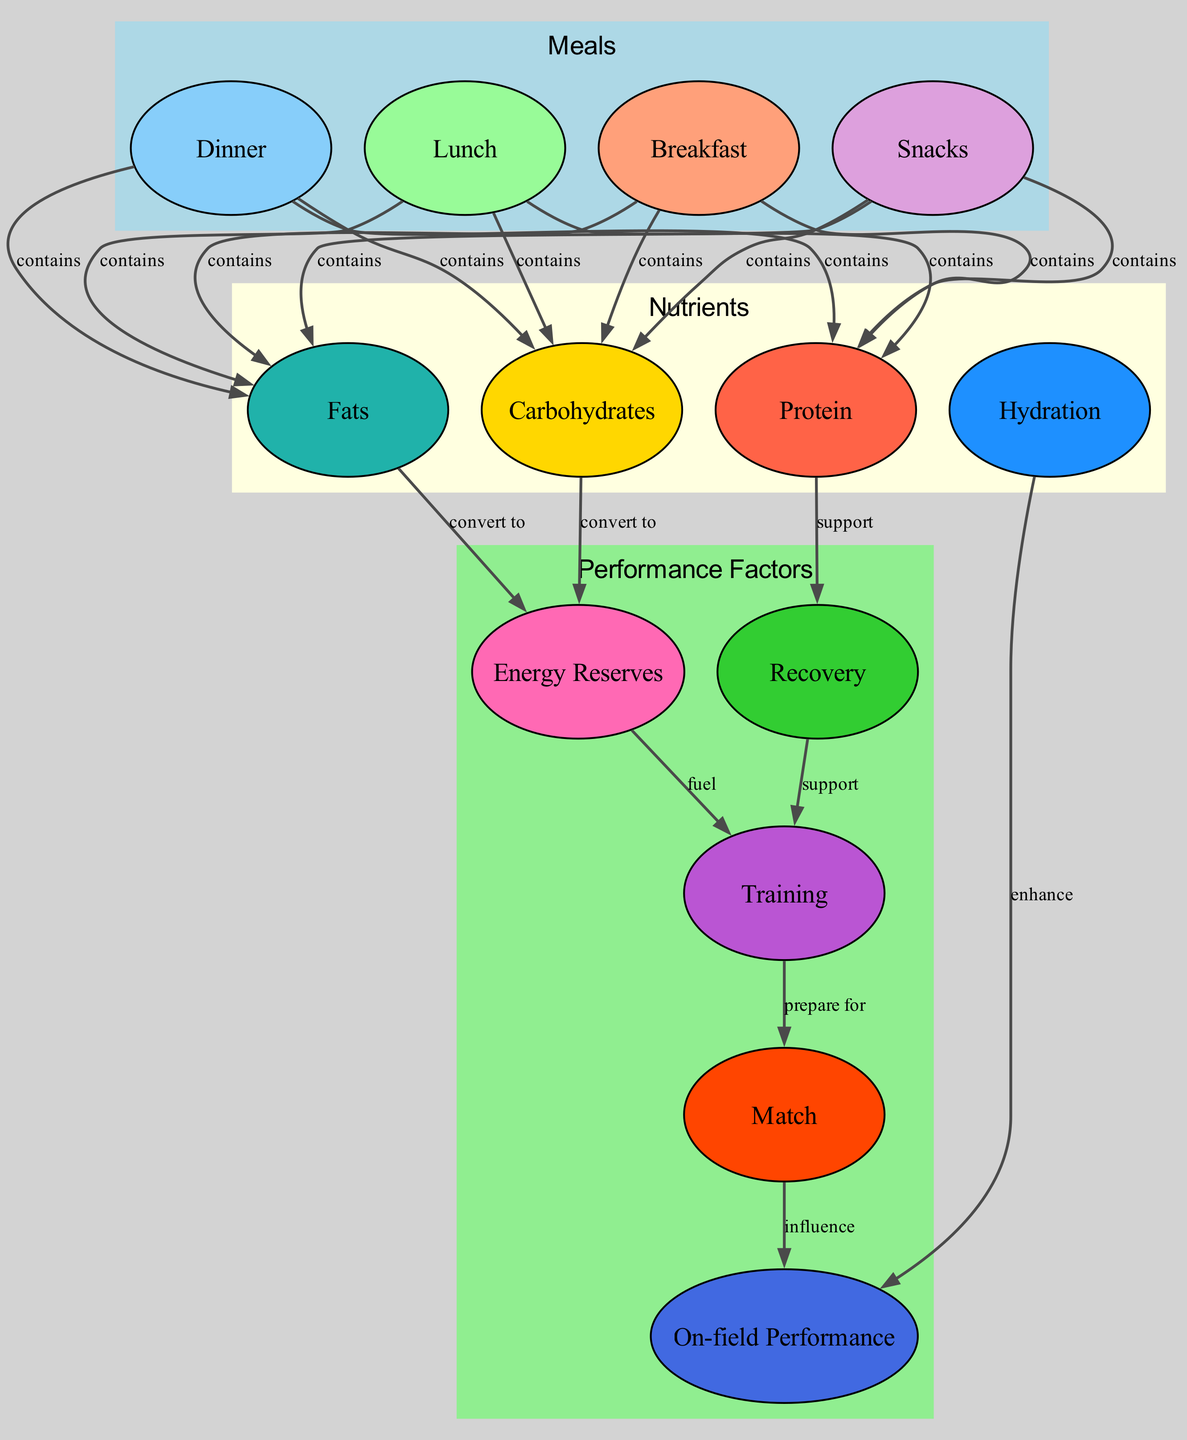What components are in breakfast? Breakfast contains carbohydrates, protein, and fats, as indicated by the edges leading from the "breakfast" node to the nutrient nodes.
Answer: carbohydrates, protein, fats How many meals are represented in the diagram? Four meals are represented: breakfast, lunch, dinner, and snacks. These are depicted as nodes in the "Meals" cluster.
Answer: 4 What nutrient supports recovery? Protein supports recovery, as indicated by the edge connecting the protein node to the recovery node with the label "support."
Answer: protein Which meal is directly linked to on-field performance through hydration? Hydration directly enhances performance, as shown by the direct edge connecting the hydration node to the performance node. The link indicates the importance of hydration in influencing performance.
Answer: hydration What is the relationship between energy reserves and training? Energy reserves fuel training, as shown by the edge connecting the energy reserve node to the training node. This indicates that energy reserves are necessary for effective training.
Answer: fuel How many total edges connect the meals to nutrients? There are 16 edges that connect the meals to the nutrients, as each meal has connections to carbohydrates, protein, and fats and there are four meals.
Answer: 16 Which meal category is represented by the color lightblue? The lightblue color represents the "Meals" category, which includes breakfast, lunch, dinner, and snacks. This is specified in the subgraph attributes.
Answer: Meals Which nutrient is converted to energy reserves? Carbohydrates and fats are converted to energy reserves, as indicated by the edges leading from the carbohydrates and fats nodes to the energy reserve node.
Answer: carbohydrates, fats What influences on-field performance from the training? Match influences on-field performance, as indicated by the edge that connects the match node to the performance node, showing that the match prepares players for performance.
Answer: match 